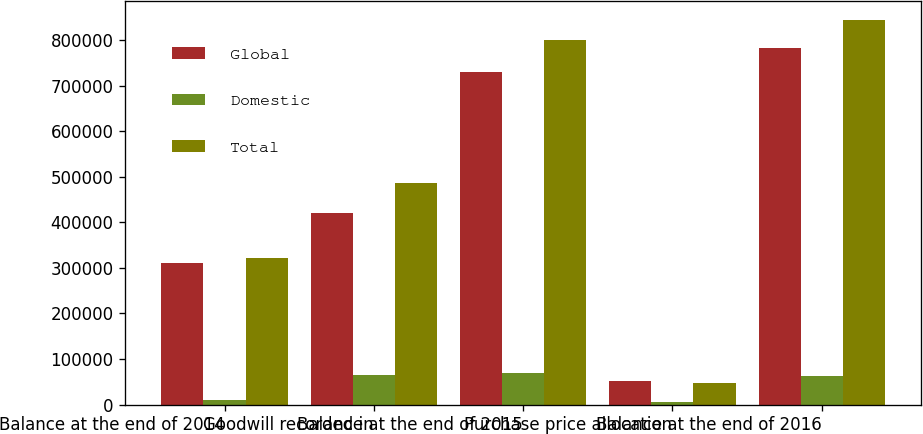Convert chart. <chart><loc_0><loc_0><loc_500><loc_500><stacked_bar_chart><ecel><fcel>Balance at the end of 2014<fcel>Goodwill recorded in<fcel>Balance at the end of 2015<fcel>Purchase price allocation<fcel>Balance at the end of 2016<nl><fcel>Global<fcel>311170<fcel>419667<fcel>730837<fcel>51827<fcel>782664<nl><fcel>Domestic<fcel>9368<fcel>65720<fcel>68345<fcel>4887<fcel>61536<nl><fcel>Total<fcel>320538<fcel>485387<fcel>799182<fcel>46940<fcel>844200<nl></chart> 